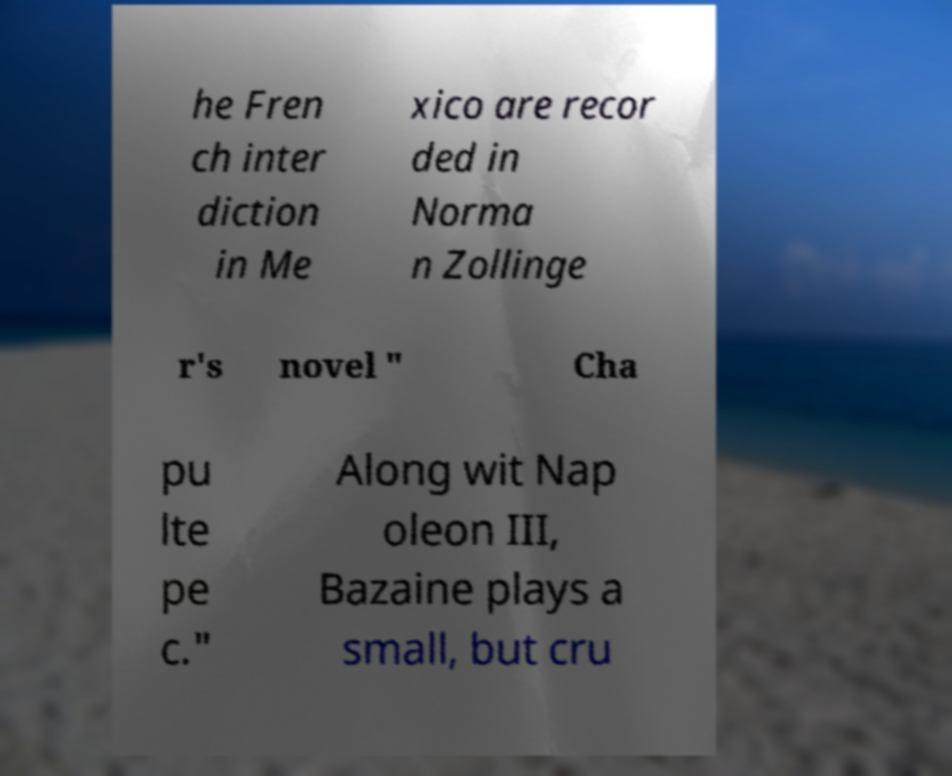For documentation purposes, I need the text within this image transcribed. Could you provide that? he Fren ch inter diction in Me xico are recor ded in Norma n Zollinge r's novel " Cha pu lte pe c." Along wit Nap oleon III, Bazaine plays a small, but cru 